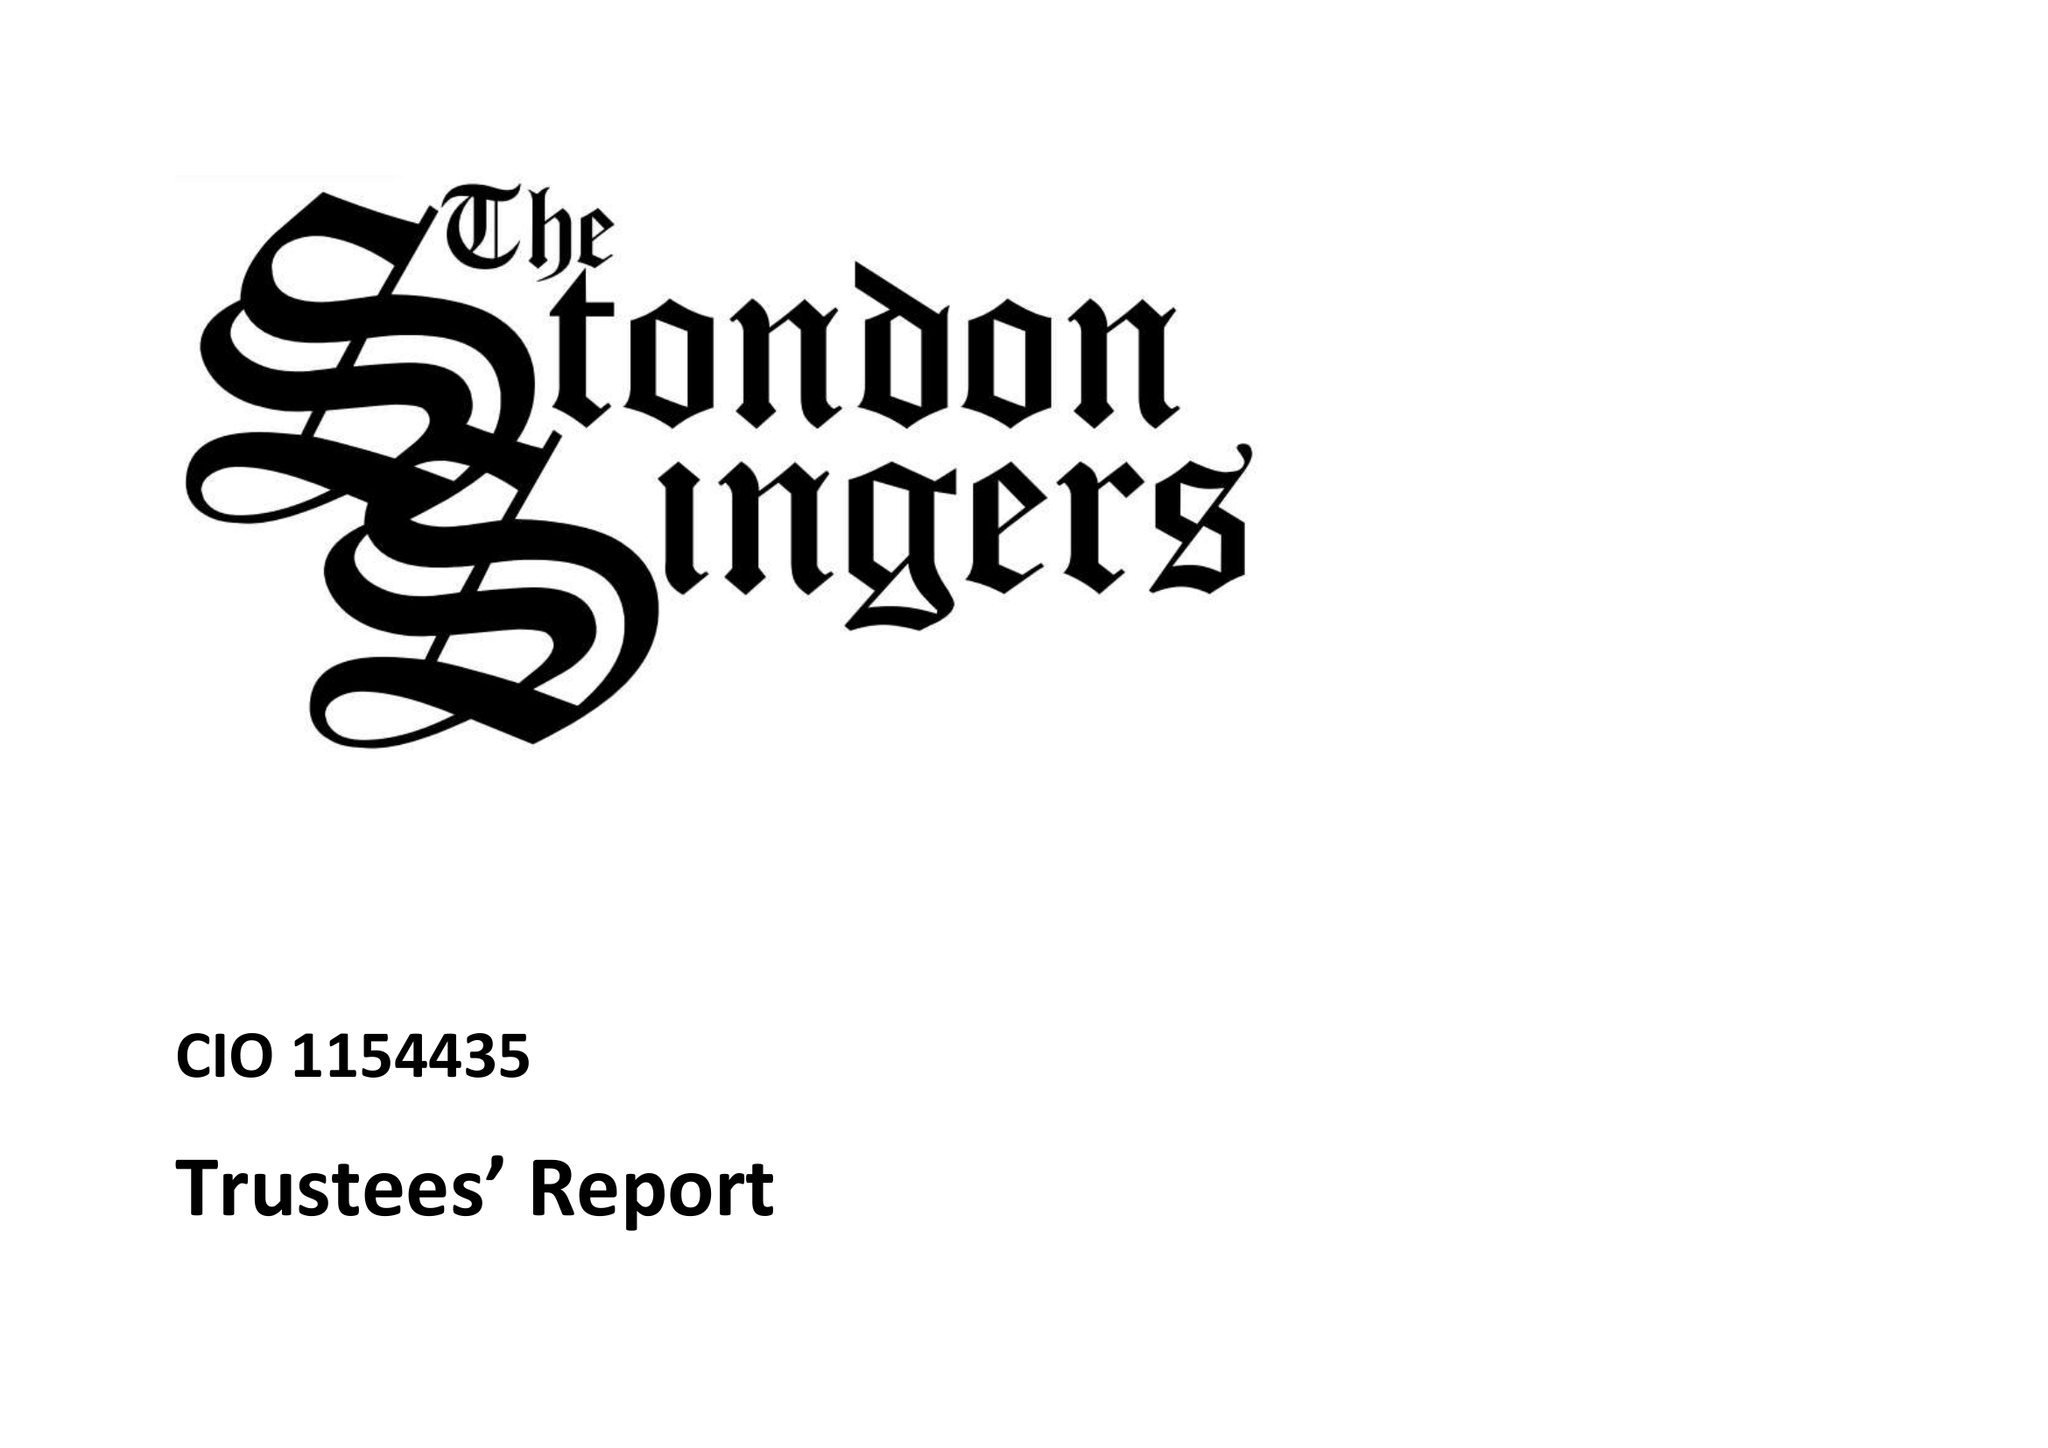What is the value for the charity_name?
Answer the question using a single word or phrase. The Stondon Singers 